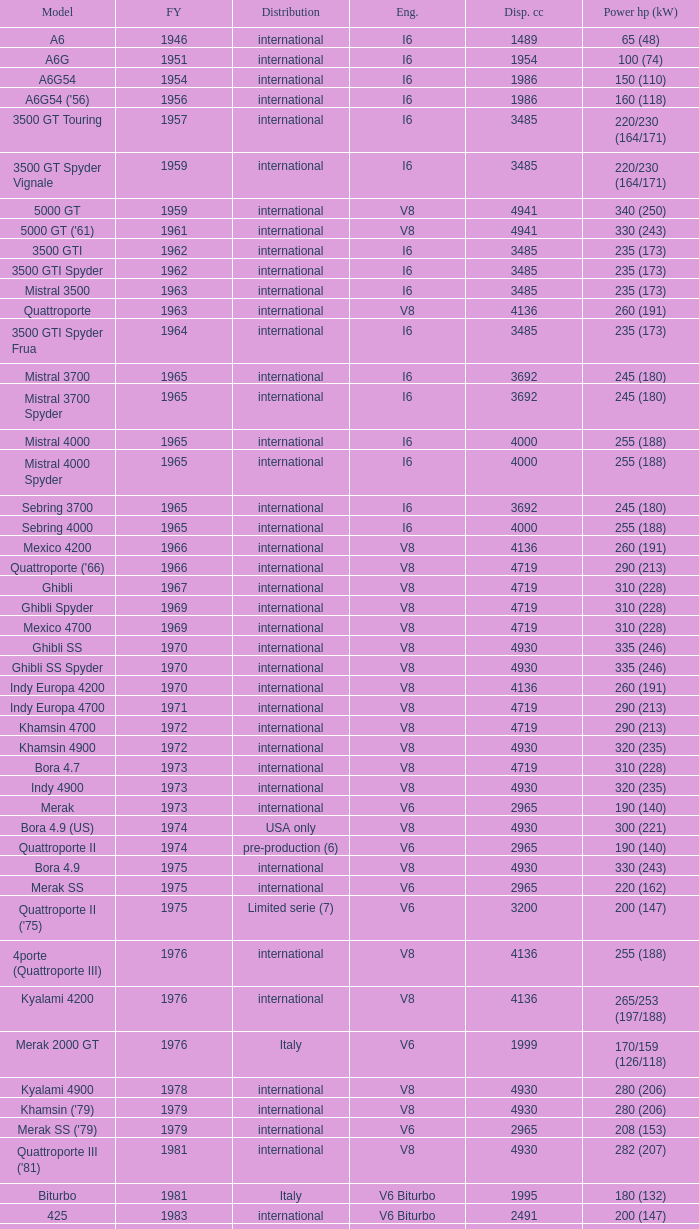What is the total number of First Year, when Displacement CC is greater than 4719, when Engine is V8, when Power HP (kW) is "335 (246)", and when Model is "Ghibli SS"? 1.0. 